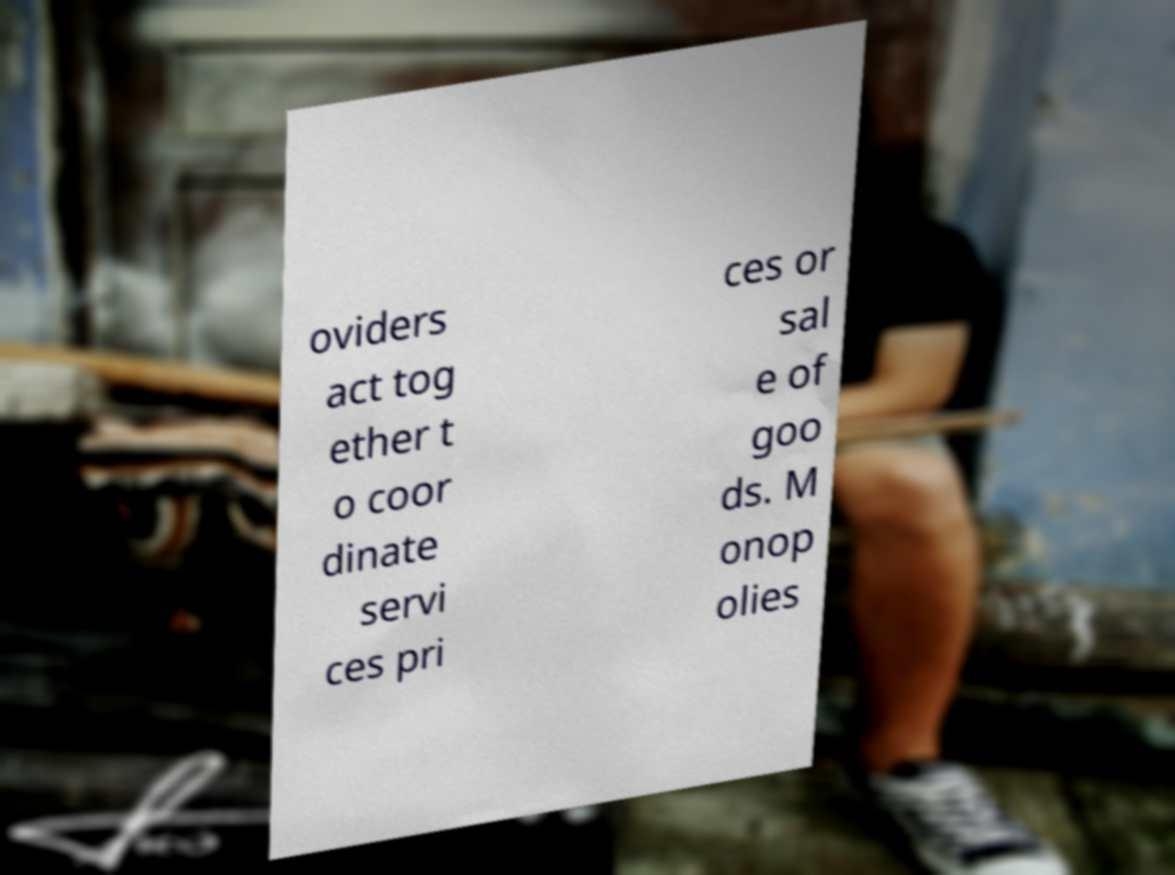Please identify and transcribe the text found in this image. oviders act tog ether t o coor dinate servi ces pri ces or sal e of goo ds. M onop olies 